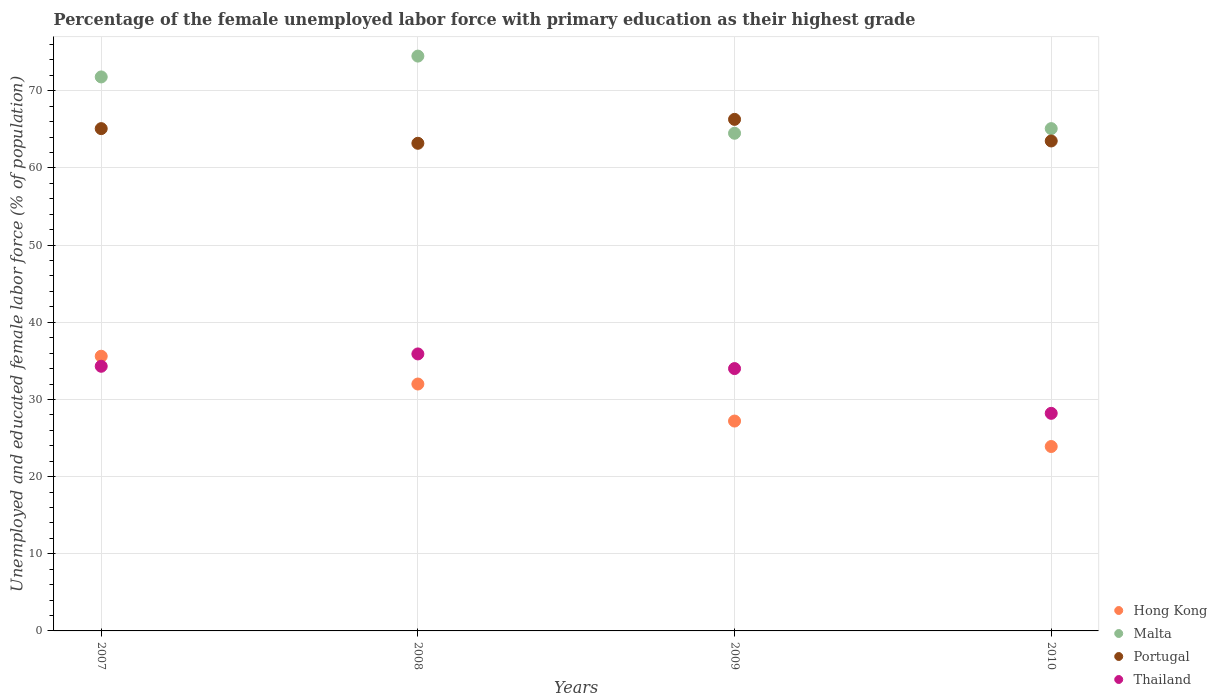What is the percentage of the unemployed female labor force with primary education in Malta in 2009?
Provide a succinct answer. 64.5. Across all years, what is the maximum percentage of the unemployed female labor force with primary education in Malta?
Your answer should be very brief. 74.5. Across all years, what is the minimum percentage of the unemployed female labor force with primary education in Portugal?
Provide a succinct answer. 63.2. In which year was the percentage of the unemployed female labor force with primary education in Thailand maximum?
Offer a very short reply. 2008. In which year was the percentage of the unemployed female labor force with primary education in Hong Kong minimum?
Ensure brevity in your answer.  2010. What is the total percentage of the unemployed female labor force with primary education in Malta in the graph?
Give a very brief answer. 275.9. What is the difference between the percentage of the unemployed female labor force with primary education in Hong Kong in 2007 and that in 2010?
Provide a short and direct response. 11.7. What is the difference between the percentage of the unemployed female labor force with primary education in Thailand in 2010 and the percentage of the unemployed female labor force with primary education in Hong Kong in 2008?
Give a very brief answer. -3.8. What is the average percentage of the unemployed female labor force with primary education in Portugal per year?
Make the answer very short. 64.53. In the year 2010, what is the difference between the percentage of the unemployed female labor force with primary education in Thailand and percentage of the unemployed female labor force with primary education in Portugal?
Offer a terse response. -35.3. What is the ratio of the percentage of the unemployed female labor force with primary education in Thailand in 2007 to that in 2008?
Give a very brief answer. 0.96. What is the difference between the highest and the second highest percentage of the unemployed female labor force with primary education in Malta?
Make the answer very short. 2.7. What is the difference between the highest and the lowest percentage of the unemployed female labor force with primary education in Thailand?
Your response must be concise. 7.7. In how many years, is the percentage of the unemployed female labor force with primary education in Thailand greater than the average percentage of the unemployed female labor force with primary education in Thailand taken over all years?
Offer a very short reply. 3. Is the sum of the percentage of the unemployed female labor force with primary education in Portugal in 2008 and 2010 greater than the maximum percentage of the unemployed female labor force with primary education in Thailand across all years?
Your response must be concise. Yes. Is it the case that in every year, the sum of the percentage of the unemployed female labor force with primary education in Malta and percentage of the unemployed female labor force with primary education in Thailand  is greater than the percentage of the unemployed female labor force with primary education in Hong Kong?
Provide a succinct answer. Yes. Does the percentage of the unemployed female labor force with primary education in Hong Kong monotonically increase over the years?
Your answer should be very brief. No. How many dotlines are there?
Your response must be concise. 4. How many years are there in the graph?
Give a very brief answer. 4. Are the values on the major ticks of Y-axis written in scientific E-notation?
Your answer should be compact. No. Does the graph contain any zero values?
Provide a short and direct response. No. Does the graph contain grids?
Offer a very short reply. Yes. What is the title of the graph?
Offer a very short reply. Percentage of the female unemployed labor force with primary education as their highest grade. What is the label or title of the Y-axis?
Keep it short and to the point. Unemployed and educated female labor force (% of population). What is the Unemployed and educated female labor force (% of population) of Hong Kong in 2007?
Your response must be concise. 35.6. What is the Unemployed and educated female labor force (% of population) of Malta in 2007?
Keep it short and to the point. 71.8. What is the Unemployed and educated female labor force (% of population) in Portugal in 2007?
Keep it short and to the point. 65.1. What is the Unemployed and educated female labor force (% of population) of Thailand in 2007?
Give a very brief answer. 34.3. What is the Unemployed and educated female labor force (% of population) in Hong Kong in 2008?
Keep it short and to the point. 32. What is the Unemployed and educated female labor force (% of population) in Malta in 2008?
Provide a succinct answer. 74.5. What is the Unemployed and educated female labor force (% of population) of Portugal in 2008?
Keep it short and to the point. 63.2. What is the Unemployed and educated female labor force (% of population) of Thailand in 2008?
Your answer should be compact. 35.9. What is the Unemployed and educated female labor force (% of population) in Hong Kong in 2009?
Give a very brief answer. 27.2. What is the Unemployed and educated female labor force (% of population) of Malta in 2009?
Make the answer very short. 64.5. What is the Unemployed and educated female labor force (% of population) of Portugal in 2009?
Ensure brevity in your answer.  66.3. What is the Unemployed and educated female labor force (% of population) in Thailand in 2009?
Your answer should be very brief. 34. What is the Unemployed and educated female labor force (% of population) in Hong Kong in 2010?
Your response must be concise. 23.9. What is the Unemployed and educated female labor force (% of population) of Malta in 2010?
Make the answer very short. 65.1. What is the Unemployed and educated female labor force (% of population) in Portugal in 2010?
Make the answer very short. 63.5. What is the Unemployed and educated female labor force (% of population) in Thailand in 2010?
Your response must be concise. 28.2. Across all years, what is the maximum Unemployed and educated female labor force (% of population) in Hong Kong?
Your answer should be very brief. 35.6. Across all years, what is the maximum Unemployed and educated female labor force (% of population) in Malta?
Provide a succinct answer. 74.5. Across all years, what is the maximum Unemployed and educated female labor force (% of population) in Portugal?
Provide a short and direct response. 66.3. Across all years, what is the maximum Unemployed and educated female labor force (% of population) of Thailand?
Provide a succinct answer. 35.9. Across all years, what is the minimum Unemployed and educated female labor force (% of population) of Hong Kong?
Provide a succinct answer. 23.9. Across all years, what is the minimum Unemployed and educated female labor force (% of population) of Malta?
Ensure brevity in your answer.  64.5. Across all years, what is the minimum Unemployed and educated female labor force (% of population) of Portugal?
Offer a terse response. 63.2. Across all years, what is the minimum Unemployed and educated female labor force (% of population) of Thailand?
Ensure brevity in your answer.  28.2. What is the total Unemployed and educated female labor force (% of population) of Hong Kong in the graph?
Keep it short and to the point. 118.7. What is the total Unemployed and educated female labor force (% of population) in Malta in the graph?
Your response must be concise. 275.9. What is the total Unemployed and educated female labor force (% of population) of Portugal in the graph?
Give a very brief answer. 258.1. What is the total Unemployed and educated female labor force (% of population) in Thailand in the graph?
Offer a terse response. 132.4. What is the difference between the Unemployed and educated female labor force (% of population) in Hong Kong in 2007 and that in 2008?
Give a very brief answer. 3.6. What is the difference between the Unemployed and educated female labor force (% of population) in Portugal in 2007 and that in 2008?
Make the answer very short. 1.9. What is the difference between the Unemployed and educated female labor force (% of population) in Malta in 2007 and that in 2009?
Provide a short and direct response. 7.3. What is the difference between the Unemployed and educated female labor force (% of population) of Thailand in 2007 and that in 2009?
Keep it short and to the point. 0.3. What is the difference between the Unemployed and educated female labor force (% of population) of Hong Kong in 2007 and that in 2010?
Offer a very short reply. 11.7. What is the difference between the Unemployed and educated female labor force (% of population) in Malta in 2007 and that in 2010?
Provide a short and direct response. 6.7. What is the difference between the Unemployed and educated female labor force (% of population) in Portugal in 2007 and that in 2010?
Keep it short and to the point. 1.6. What is the difference between the Unemployed and educated female labor force (% of population) of Hong Kong in 2008 and that in 2009?
Provide a succinct answer. 4.8. What is the difference between the Unemployed and educated female labor force (% of population) in Malta in 2008 and that in 2009?
Keep it short and to the point. 10. What is the difference between the Unemployed and educated female labor force (% of population) of Thailand in 2008 and that in 2009?
Keep it short and to the point. 1.9. What is the difference between the Unemployed and educated female labor force (% of population) of Thailand in 2008 and that in 2010?
Make the answer very short. 7.7. What is the difference between the Unemployed and educated female labor force (% of population) in Malta in 2009 and that in 2010?
Keep it short and to the point. -0.6. What is the difference between the Unemployed and educated female labor force (% of population) of Portugal in 2009 and that in 2010?
Offer a very short reply. 2.8. What is the difference between the Unemployed and educated female labor force (% of population) of Thailand in 2009 and that in 2010?
Provide a short and direct response. 5.8. What is the difference between the Unemployed and educated female labor force (% of population) of Hong Kong in 2007 and the Unemployed and educated female labor force (% of population) of Malta in 2008?
Your answer should be very brief. -38.9. What is the difference between the Unemployed and educated female labor force (% of population) in Hong Kong in 2007 and the Unemployed and educated female labor force (% of population) in Portugal in 2008?
Keep it short and to the point. -27.6. What is the difference between the Unemployed and educated female labor force (% of population) of Malta in 2007 and the Unemployed and educated female labor force (% of population) of Thailand in 2008?
Provide a succinct answer. 35.9. What is the difference between the Unemployed and educated female labor force (% of population) of Portugal in 2007 and the Unemployed and educated female labor force (% of population) of Thailand in 2008?
Keep it short and to the point. 29.2. What is the difference between the Unemployed and educated female labor force (% of population) in Hong Kong in 2007 and the Unemployed and educated female labor force (% of population) in Malta in 2009?
Provide a short and direct response. -28.9. What is the difference between the Unemployed and educated female labor force (% of population) of Hong Kong in 2007 and the Unemployed and educated female labor force (% of population) of Portugal in 2009?
Your answer should be very brief. -30.7. What is the difference between the Unemployed and educated female labor force (% of population) of Hong Kong in 2007 and the Unemployed and educated female labor force (% of population) of Thailand in 2009?
Your answer should be compact. 1.6. What is the difference between the Unemployed and educated female labor force (% of population) in Malta in 2007 and the Unemployed and educated female labor force (% of population) in Thailand in 2009?
Your response must be concise. 37.8. What is the difference between the Unemployed and educated female labor force (% of population) in Portugal in 2007 and the Unemployed and educated female labor force (% of population) in Thailand in 2009?
Your answer should be very brief. 31.1. What is the difference between the Unemployed and educated female labor force (% of population) of Hong Kong in 2007 and the Unemployed and educated female labor force (% of population) of Malta in 2010?
Make the answer very short. -29.5. What is the difference between the Unemployed and educated female labor force (% of population) of Hong Kong in 2007 and the Unemployed and educated female labor force (% of population) of Portugal in 2010?
Offer a terse response. -27.9. What is the difference between the Unemployed and educated female labor force (% of population) of Malta in 2007 and the Unemployed and educated female labor force (% of population) of Thailand in 2010?
Keep it short and to the point. 43.6. What is the difference between the Unemployed and educated female labor force (% of population) of Portugal in 2007 and the Unemployed and educated female labor force (% of population) of Thailand in 2010?
Provide a short and direct response. 36.9. What is the difference between the Unemployed and educated female labor force (% of population) in Hong Kong in 2008 and the Unemployed and educated female labor force (% of population) in Malta in 2009?
Provide a short and direct response. -32.5. What is the difference between the Unemployed and educated female labor force (% of population) in Hong Kong in 2008 and the Unemployed and educated female labor force (% of population) in Portugal in 2009?
Make the answer very short. -34.3. What is the difference between the Unemployed and educated female labor force (% of population) of Malta in 2008 and the Unemployed and educated female labor force (% of population) of Thailand in 2009?
Give a very brief answer. 40.5. What is the difference between the Unemployed and educated female labor force (% of population) in Portugal in 2008 and the Unemployed and educated female labor force (% of population) in Thailand in 2009?
Your response must be concise. 29.2. What is the difference between the Unemployed and educated female labor force (% of population) in Hong Kong in 2008 and the Unemployed and educated female labor force (% of population) in Malta in 2010?
Your answer should be compact. -33.1. What is the difference between the Unemployed and educated female labor force (% of population) of Hong Kong in 2008 and the Unemployed and educated female labor force (% of population) of Portugal in 2010?
Offer a terse response. -31.5. What is the difference between the Unemployed and educated female labor force (% of population) of Hong Kong in 2008 and the Unemployed and educated female labor force (% of population) of Thailand in 2010?
Your answer should be very brief. 3.8. What is the difference between the Unemployed and educated female labor force (% of population) of Malta in 2008 and the Unemployed and educated female labor force (% of population) of Thailand in 2010?
Your answer should be compact. 46.3. What is the difference between the Unemployed and educated female labor force (% of population) in Hong Kong in 2009 and the Unemployed and educated female labor force (% of population) in Malta in 2010?
Keep it short and to the point. -37.9. What is the difference between the Unemployed and educated female labor force (% of population) of Hong Kong in 2009 and the Unemployed and educated female labor force (% of population) of Portugal in 2010?
Give a very brief answer. -36.3. What is the difference between the Unemployed and educated female labor force (% of population) of Hong Kong in 2009 and the Unemployed and educated female labor force (% of population) of Thailand in 2010?
Offer a very short reply. -1. What is the difference between the Unemployed and educated female labor force (% of population) in Malta in 2009 and the Unemployed and educated female labor force (% of population) in Thailand in 2010?
Your answer should be compact. 36.3. What is the difference between the Unemployed and educated female labor force (% of population) of Portugal in 2009 and the Unemployed and educated female labor force (% of population) of Thailand in 2010?
Give a very brief answer. 38.1. What is the average Unemployed and educated female labor force (% of population) in Hong Kong per year?
Keep it short and to the point. 29.68. What is the average Unemployed and educated female labor force (% of population) in Malta per year?
Make the answer very short. 68.97. What is the average Unemployed and educated female labor force (% of population) of Portugal per year?
Your answer should be compact. 64.53. What is the average Unemployed and educated female labor force (% of population) of Thailand per year?
Your answer should be compact. 33.1. In the year 2007, what is the difference between the Unemployed and educated female labor force (% of population) of Hong Kong and Unemployed and educated female labor force (% of population) of Malta?
Ensure brevity in your answer.  -36.2. In the year 2007, what is the difference between the Unemployed and educated female labor force (% of population) of Hong Kong and Unemployed and educated female labor force (% of population) of Portugal?
Your answer should be compact. -29.5. In the year 2007, what is the difference between the Unemployed and educated female labor force (% of population) in Malta and Unemployed and educated female labor force (% of population) in Thailand?
Make the answer very short. 37.5. In the year 2007, what is the difference between the Unemployed and educated female labor force (% of population) of Portugal and Unemployed and educated female labor force (% of population) of Thailand?
Ensure brevity in your answer.  30.8. In the year 2008, what is the difference between the Unemployed and educated female labor force (% of population) of Hong Kong and Unemployed and educated female labor force (% of population) of Malta?
Ensure brevity in your answer.  -42.5. In the year 2008, what is the difference between the Unemployed and educated female labor force (% of population) in Hong Kong and Unemployed and educated female labor force (% of population) in Portugal?
Your answer should be very brief. -31.2. In the year 2008, what is the difference between the Unemployed and educated female labor force (% of population) in Hong Kong and Unemployed and educated female labor force (% of population) in Thailand?
Provide a succinct answer. -3.9. In the year 2008, what is the difference between the Unemployed and educated female labor force (% of population) in Malta and Unemployed and educated female labor force (% of population) in Portugal?
Ensure brevity in your answer.  11.3. In the year 2008, what is the difference between the Unemployed and educated female labor force (% of population) of Malta and Unemployed and educated female labor force (% of population) of Thailand?
Your answer should be very brief. 38.6. In the year 2008, what is the difference between the Unemployed and educated female labor force (% of population) of Portugal and Unemployed and educated female labor force (% of population) of Thailand?
Ensure brevity in your answer.  27.3. In the year 2009, what is the difference between the Unemployed and educated female labor force (% of population) of Hong Kong and Unemployed and educated female labor force (% of population) of Malta?
Offer a very short reply. -37.3. In the year 2009, what is the difference between the Unemployed and educated female labor force (% of population) in Hong Kong and Unemployed and educated female labor force (% of population) in Portugal?
Make the answer very short. -39.1. In the year 2009, what is the difference between the Unemployed and educated female labor force (% of population) of Malta and Unemployed and educated female labor force (% of population) of Thailand?
Make the answer very short. 30.5. In the year 2009, what is the difference between the Unemployed and educated female labor force (% of population) of Portugal and Unemployed and educated female labor force (% of population) of Thailand?
Offer a terse response. 32.3. In the year 2010, what is the difference between the Unemployed and educated female labor force (% of population) in Hong Kong and Unemployed and educated female labor force (% of population) in Malta?
Your response must be concise. -41.2. In the year 2010, what is the difference between the Unemployed and educated female labor force (% of population) in Hong Kong and Unemployed and educated female labor force (% of population) in Portugal?
Make the answer very short. -39.6. In the year 2010, what is the difference between the Unemployed and educated female labor force (% of population) in Hong Kong and Unemployed and educated female labor force (% of population) in Thailand?
Make the answer very short. -4.3. In the year 2010, what is the difference between the Unemployed and educated female labor force (% of population) in Malta and Unemployed and educated female labor force (% of population) in Thailand?
Offer a terse response. 36.9. In the year 2010, what is the difference between the Unemployed and educated female labor force (% of population) of Portugal and Unemployed and educated female labor force (% of population) of Thailand?
Offer a very short reply. 35.3. What is the ratio of the Unemployed and educated female labor force (% of population) in Hong Kong in 2007 to that in 2008?
Make the answer very short. 1.11. What is the ratio of the Unemployed and educated female labor force (% of population) in Malta in 2007 to that in 2008?
Provide a succinct answer. 0.96. What is the ratio of the Unemployed and educated female labor force (% of population) in Portugal in 2007 to that in 2008?
Your answer should be very brief. 1.03. What is the ratio of the Unemployed and educated female labor force (% of population) of Thailand in 2007 to that in 2008?
Offer a very short reply. 0.96. What is the ratio of the Unemployed and educated female labor force (% of population) in Hong Kong in 2007 to that in 2009?
Your answer should be very brief. 1.31. What is the ratio of the Unemployed and educated female labor force (% of population) in Malta in 2007 to that in 2009?
Make the answer very short. 1.11. What is the ratio of the Unemployed and educated female labor force (% of population) in Portugal in 2007 to that in 2009?
Keep it short and to the point. 0.98. What is the ratio of the Unemployed and educated female labor force (% of population) of Thailand in 2007 to that in 2009?
Give a very brief answer. 1.01. What is the ratio of the Unemployed and educated female labor force (% of population) of Hong Kong in 2007 to that in 2010?
Ensure brevity in your answer.  1.49. What is the ratio of the Unemployed and educated female labor force (% of population) of Malta in 2007 to that in 2010?
Provide a short and direct response. 1.1. What is the ratio of the Unemployed and educated female labor force (% of population) of Portugal in 2007 to that in 2010?
Provide a succinct answer. 1.03. What is the ratio of the Unemployed and educated female labor force (% of population) of Thailand in 2007 to that in 2010?
Ensure brevity in your answer.  1.22. What is the ratio of the Unemployed and educated female labor force (% of population) in Hong Kong in 2008 to that in 2009?
Provide a short and direct response. 1.18. What is the ratio of the Unemployed and educated female labor force (% of population) of Malta in 2008 to that in 2009?
Your response must be concise. 1.16. What is the ratio of the Unemployed and educated female labor force (% of population) in Portugal in 2008 to that in 2009?
Make the answer very short. 0.95. What is the ratio of the Unemployed and educated female labor force (% of population) in Thailand in 2008 to that in 2009?
Ensure brevity in your answer.  1.06. What is the ratio of the Unemployed and educated female labor force (% of population) of Hong Kong in 2008 to that in 2010?
Make the answer very short. 1.34. What is the ratio of the Unemployed and educated female labor force (% of population) in Malta in 2008 to that in 2010?
Offer a very short reply. 1.14. What is the ratio of the Unemployed and educated female labor force (% of population) in Portugal in 2008 to that in 2010?
Provide a short and direct response. 1. What is the ratio of the Unemployed and educated female labor force (% of population) of Thailand in 2008 to that in 2010?
Your response must be concise. 1.27. What is the ratio of the Unemployed and educated female labor force (% of population) in Hong Kong in 2009 to that in 2010?
Keep it short and to the point. 1.14. What is the ratio of the Unemployed and educated female labor force (% of population) of Malta in 2009 to that in 2010?
Provide a short and direct response. 0.99. What is the ratio of the Unemployed and educated female labor force (% of population) in Portugal in 2009 to that in 2010?
Offer a very short reply. 1.04. What is the ratio of the Unemployed and educated female labor force (% of population) in Thailand in 2009 to that in 2010?
Ensure brevity in your answer.  1.21. What is the difference between the highest and the second highest Unemployed and educated female labor force (% of population) in Hong Kong?
Offer a very short reply. 3.6. What is the difference between the highest and the second highest Unemployed and educated female labor force (% of population) of Malta?
Ensure brevity in your answer.  2.7. What is the difference between the highest and the second highest Unemployed and educated female labor force (% of population) in Portugal?
Your response must be concise. 1.2. What is the difference between the highest and the second highest Unemployed and educated female labor force (% of population) of Thailand?
Keep it short and to the point. 1.6. 